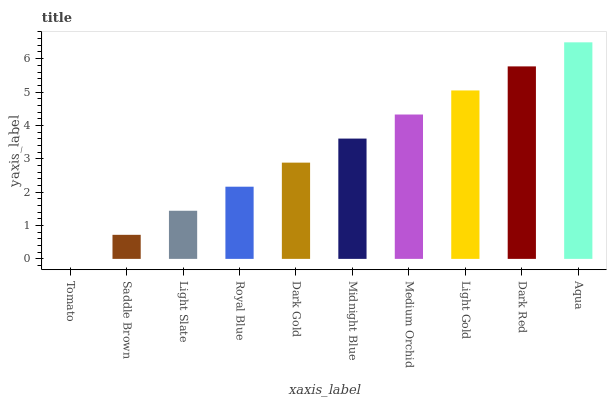Is Tomato the minimum?
Answer yes or no. Yes. Is Aqua the maximum?
Answer yes or no. Yes. Is Saddle Brown the minimum?
Answer yes or no. No. Is Saddle Brown the maximum?
Answer yes or no. No. Is Saddle Brown greater than Tomato?
Answer yes or no. Yes. Is Tomato less than Saddle Brown?
Answer yes or no. Yes. Is Tomato greater than Saddle Brown?
Answer yes or no. No. Is Saddle Brown less than Tomato?
Answer yes or no. No. Is Midnight Blue the high median?
Answer yes or no. Yes. Is Dark Gold the low median?
Answer yes or no. Yes. Is Medium Orchid the high median?
Answer yes or no. No. Is Royal Blue the low median?
Answer yes or no. No. 